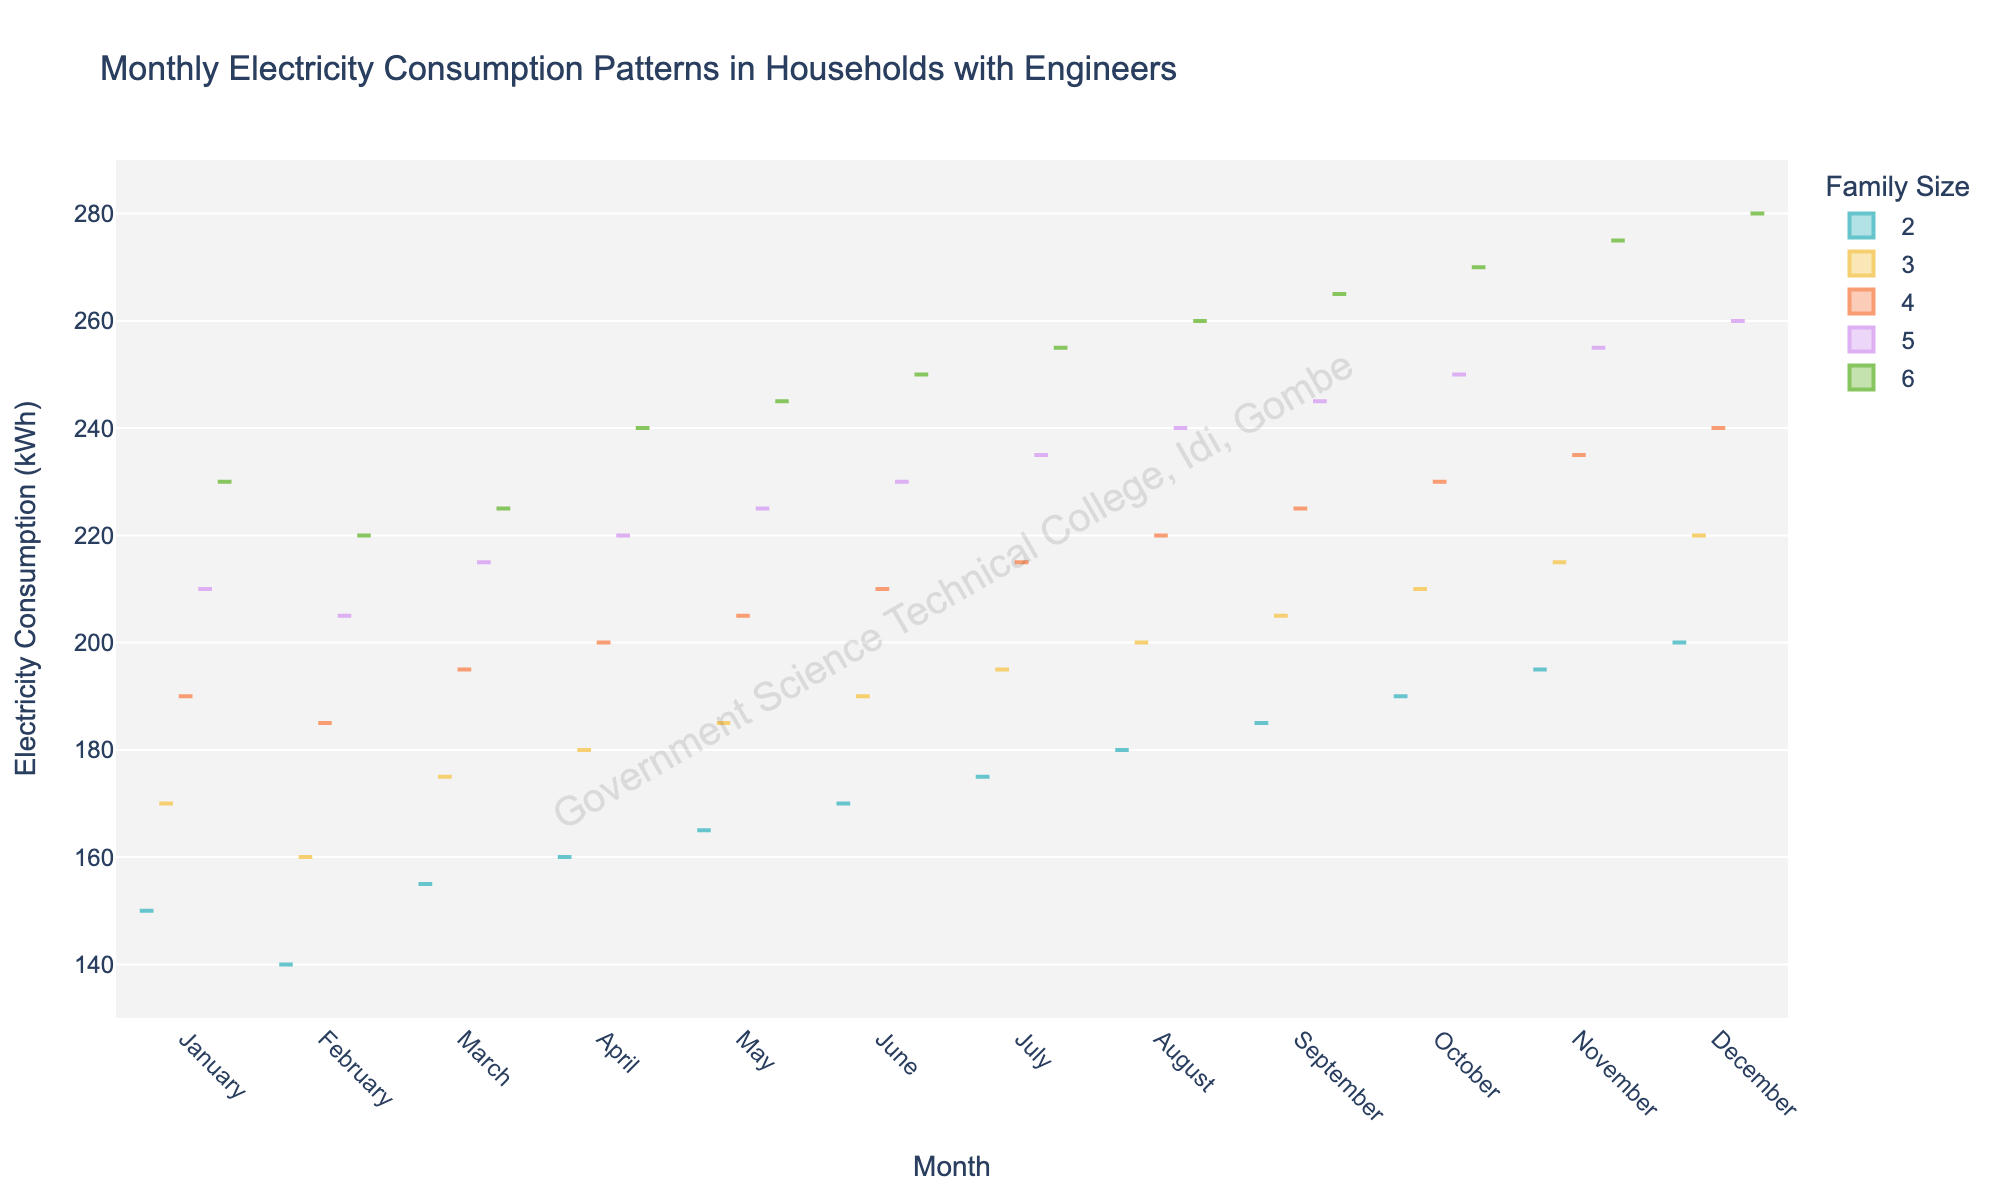What is the title of the violin plot? The title is usually placed at the top center of the plot and it indicates what the plot is about.
Answer: Monthly Electricity Consumption Patterns in Households with Engineers Which month has the highest electricity consumption for a family size of 6? The highest value for family size of 6 can be found by observing the vertical spread of the violin plot for each month. In December, the maximum electricity consumption for a family size of 6 is the highest.
Answer: December What is the range of electricity consumption displayed on the y-axis? The y-axis range can be determined by checking the y-ticks values at the ends of the violin plot. The axis is labeled from 130 kWh to 290 kWh.
Answer: 130 to 290 kWh In which month does a family of 5 consume around 260 kWh? Look for the month where the violin plot for family size 5 extends to approximately 260 kWh. The plot in December for family size 5 reaches this value.
Answer: December How does the median electricity consumption for family size of 3 change from January to December? For the median, observe the thick part near the middle of each violin plot. The consumption for family size of 3 gradually increases from about 170 kWh in January to about 220 kWh in December.
Answer: Increases Which family size has the most variation in electricity consumption in March? The family size with the widest or most spread out violin plot indicates the most variation. Family size 5 in March shows the widest range of consumption.
Answer: Family size 5 Compare the electricity consumption patterns in July and August for family size 2. Compare the violin plots of July and August specifically for family size 2 by looking at their spreads and central tendencies. Both months have similar patterns with values ranging around 175 kWh to 180 kWh for July and increasing slightly to around 180 kWh to 185 kWh for August.
Answer: Slight increase in August What is the central tendency of electricity consumption in May for family size of 4? The central tendency can be determined by looking at the thickest part of the violin plot for family size 4 in May, which appears to be around 205 kWh.
Answer: Around 205 kWh During which months does the electricity consumption for a family size of 5 overlap with that of a family size of 6? Check for months where the violin plots for family sizes 5 and 6 share a common range. This happens notably in July through December where there's a significant overlap.
Answer: July through December 